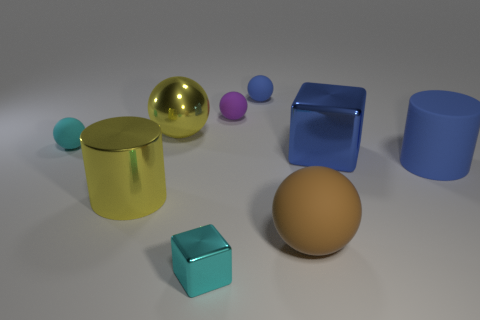Can you describe the lighting setup based on the shadows and highlights you see? From the shadows and highlights, it seems like the lighting in this image likely comes from above or slightly to one side, casting soft-edged shadows predominantly to the opposite side of the light source, suggesting a somewhat diffused light rather than a point source. 